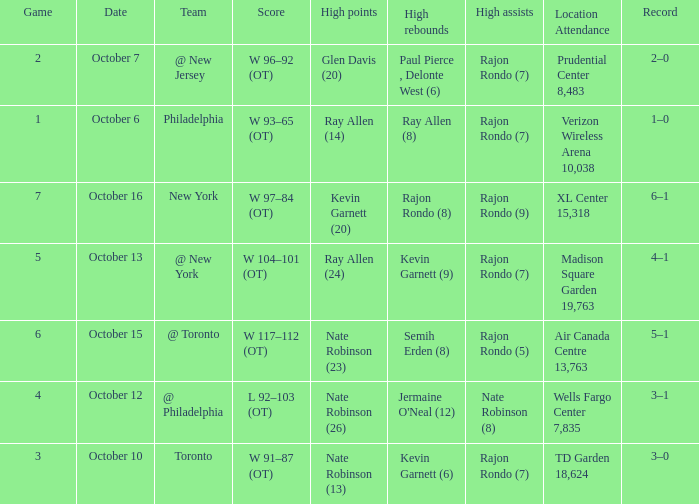Who had the most rebounds and how many did they have on October 16? Rajon Rondo (8). 